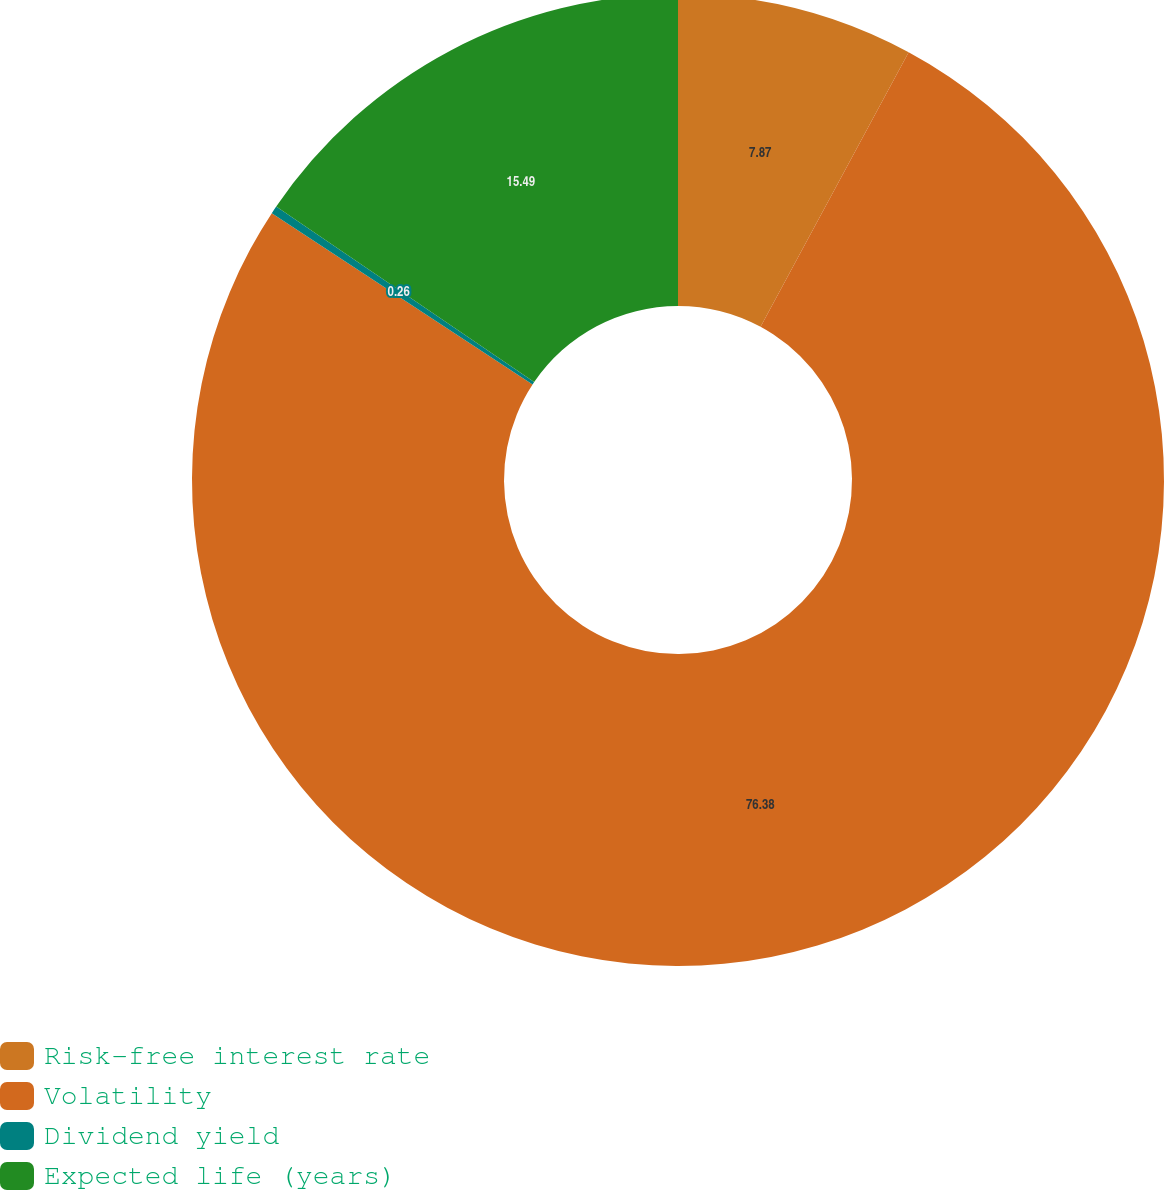<chart> <loc_0><loc_0><loc_500><loc_500><pie_chart><fcel>Risk-free interest rate<fcel>Volatility<fcel>Dividend yield<fcel>Expected life (years)<nl><fcel>7.87%<fcel>76.38%<fcel>0.26%<fcel>15.49%<nl></chart> 